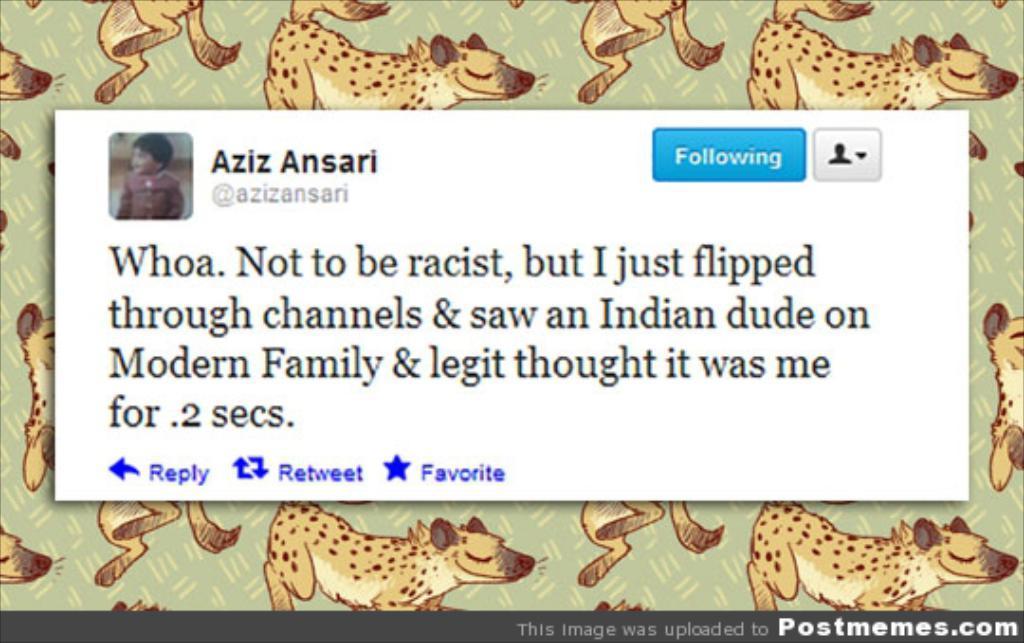Can you describe this image briefly? In this image I see something is written over here and I see a picture of a child over here and I see the depiction of animal pictures and I see something is written over here too. 